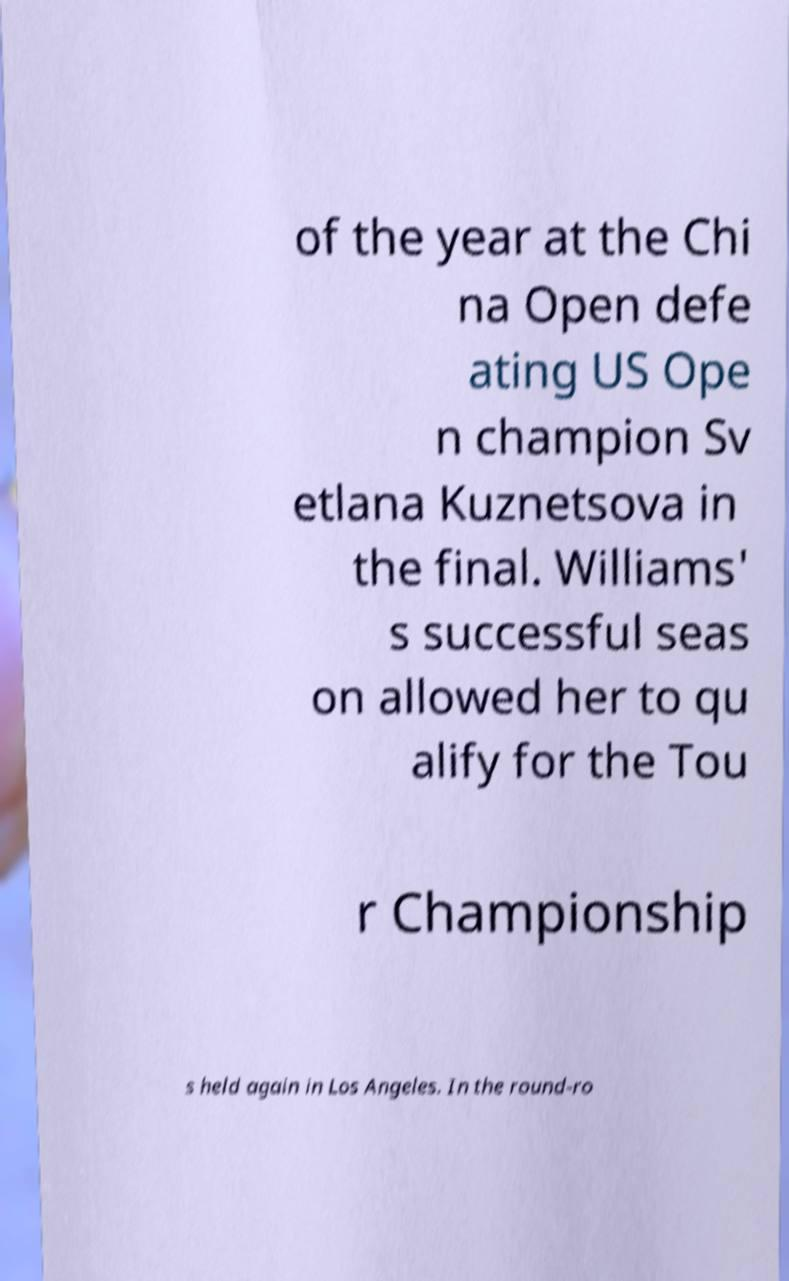There's text embedded in this image that I need extracted. Can you transcribe it verbatim? of the year at the Chi na Open defe ating US Ope n champion Sv etlana Kuznetsova in the final. Williams' s successful seas on allowed her to qu alify for the Tou r Championship s held again in Los Angeles. In the round-ro 